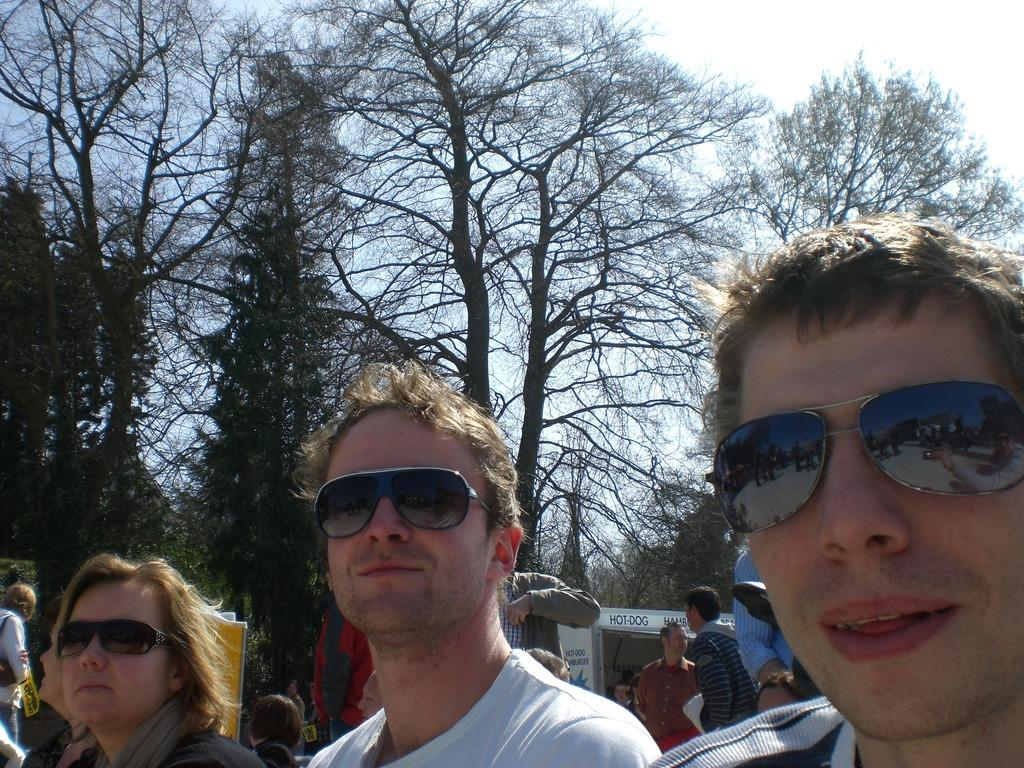<image>
Write a terse but informative summary of the picture. Three people taking a photo in front of a truck that says "hot dog". 